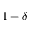<formula> <loc_0><loc_0><loc_500><loc_500>1 - \delta</formula> 